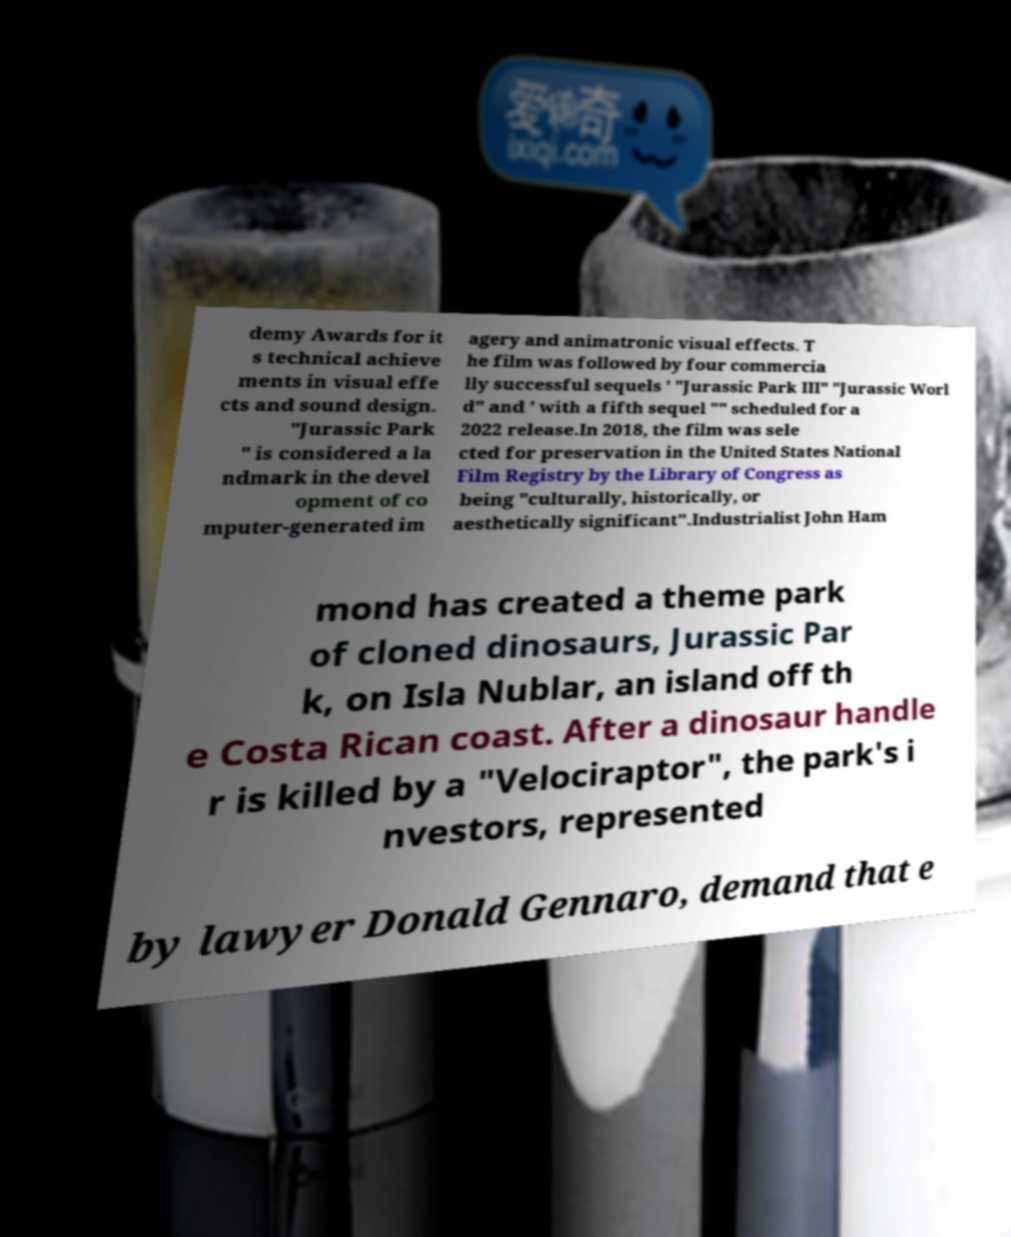Could you extract and type out the text from this image? demy Awards for it s technical achieve ments in visual effe cts and sound design. "Jurassic Park " is considered a la ndmark in the devel opment of co mputer-generated im agery and animatronic visual effects. T he film was followed by four commercia lly successful sequels ' "Jurassic Park III" "Jurassic Worl d" and ' with a fifth sequel "" scheduled for a 2022 release.In 2018, the film was sele cted for preservation in the United States National Film Registry by the Library of Congress as being "culturally, historically, or aesthetically significant".Industrialist John Ham mond has created a theme park of cloned dinosaurs, Jurassic Par k, on Isla Nublar, an island off th e Costa Rican coast. After a dinosaur handle r is killed by a "Velociraptor", the park's i nvestors, represented by lawyer Donald Gennaro, demand that e 